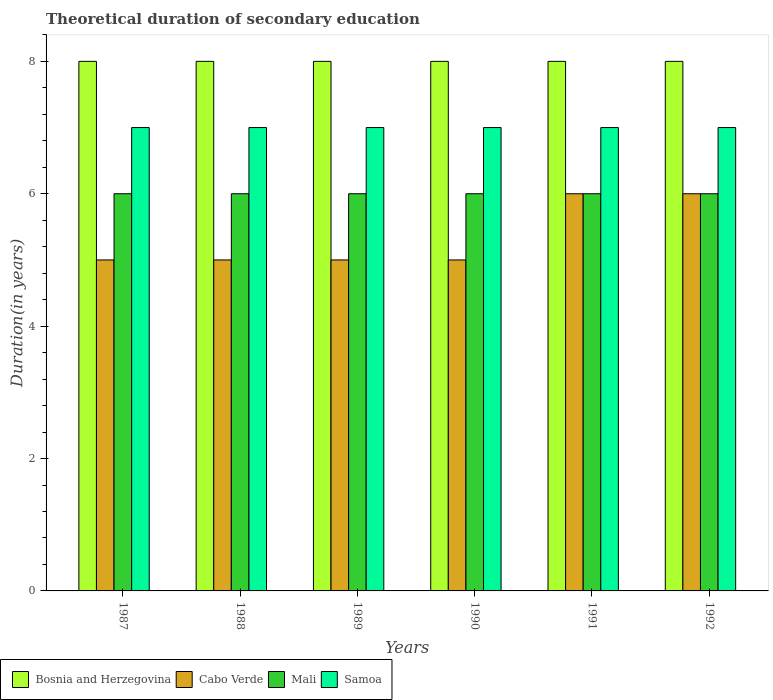How many groups of bars are there?
Your response must be concise. 6. Are the number of bars per tick equal to the number of legend labels?
Your answer should be compact. Yes. Are the number of bars on each tick of the X-axis equal?
Your response must be concise. Yes. How many bars are there on the 4th tick from the left?
Offer a very short reply. 4. How many bars are there on the 3rd tick from the right?
Your answer should be very brief. 4. What is the label of the 2nd group of bars from the left?
Offer a very short reply. 1988. In how many cases, is the number of bars for a given year not equal to the number of legend labels?
Make the answer very short. 0. What is the total theoretical duration of secondary education in Cabo Verde in 1987?
Offer a very short reply. 5. Across all years, what is the maximum total theoretical duration of secondary education in Bosnia and Herzegovina?
Keep it short and to the point. 8. Across all years, what is the minimum total theoretical duration of secondary education in Samoa?
Ensure brevity in your answer.  7. In which year was the total theoretical duration of secondary education in Cabo Verde maximum?
Your response must be concise. 1991. What is the total total theoretical duration of secondary education in Samoa in the graph?
Provide a short and direct response. 42. What is the average total theoretical duration of secondary education in Samoa per year?
Offer a terse response. 7. In the year 1992, what is the difference between the total theoretical duration of secondary education in Samoa and total theoretical duration of secondary education in Bosnia and Herzegovina?
Offer a terse response. -1. Is the difference between the total theoretical duration of secondary education in Samoa in 1987 and 1988 greater than the difference between the total theoretical duration of secondary education in Bosnia and Herzegovina in 1987 and 1988?
Give a very brief answer. No. What is the difference between the highest and the lowest total theoretical duration of secondary education in Samoa?
Give a very brief answer. 0. What does the 2nd bar from the left in 1991 represents?
Your answer should be very brief. Cabo Verde. What does the 1st bar from the right in 1990 represents?
Make the answer very short. Samoa. Is it the case that in every year, the sum of the total theoretical duration of secondary education in Samoa and total theoretical duration of secondary education in Mali is greater than the total theoretical duration of secondary education in Bosnia and Herzegovina?
Your response must be concise. Yes. How many bars are there?
Give a very brief answer. 24. How many years are there in the graph?
Ensure brevity in your answer.  6. What is the difference between two consecutive major ticks on the Y-axis?
Make the answer very short. 2. Does the graph contain any zero values?
Provide a short and direct response. No. How many legend labels are there?
Make the answer very short. 4. How are the legend labels stacked?
Your answer should be very brief. Horizontal. What is the title of the graph?
Your response must be concise. Theoretical duration of secondary education. What is the label or title of the X-axis?
Your answer should be compact. Years. What is the label or title of the Y-axis?
Provide a succinct answer. Duration(in years). What is the Duration(in years) of Mali in 1987?
Ensure brevity in your answer.  6. What is the Duration(in years) of Samoa in 1987?
Provide a succinct answer. 7. What is the Duration(in years) of Samoa in 1988?
Ensure brevity in your answer.  7. What is the Duration(in years) in Bosnia and Herzegovina in 1989?
Make the answer very short. 8. What is the Duration(in years) of Cabo Verde in 1990?
Provide a succinct answer. 5. What is the Duration(in years) of Bosnia and Herzegovina in 1991?
Keep it short and to the point. 8. What is the Duration(in years) of Mali in 1991?
Give a very brief answer. 6. What is the Duration(in years) of Bosnia and Herzegovina in 1992?
Provide a short and direct response. 8. What is the Duration(in years) in Cabo Verde in 1992?
Your answer should be compact. 6. Across all years, what is the maximum Duration(in years) of Bosnia and Herzegovina?
Your response must be concise. 8. Across all years, what is the maximum Duration(in years) in Cabo Verde?
Offer a very short reply. 6. Across all years, what is the maximum Duration(in years) in Mali?
Your answer should be very brief. 6. Across all years, what is the maximum Duration(in years) in Samoa?
Make the answer very short. 7. Across all years, what is the minimum Duration(in years) of Bosnia and Herzegovina?
Give a very brief answer. 8. Across all years, what is the minimum Duration(in years) of Samoa?
Offer a very short reply. 7. What is the total Duration(in years) of Mali in the graph?
Your answer should be very brief. 36. What is the total Duration(in years) in Samoa in the graph?
Your answer should be compact. 42. What is the difference between the Duration(in years) of Bosnia and Herzegovina in 1987 and that in 1988?
Offer a very short reply. 0. What is the difference between the Duration(in years) of Cabo Verde in 1987 and that in 1988?
Ensure brevity in your answer.  0. What is the difference between the Duration(in years) of Samoa in 1987 and that in 1988?
Your answer should be compact. 0. What is the difference between the Duration(in years) of Bosnia and Herzegovina in 1987 and that in 1989?
Provide a succinct answer. 0. What is the difference between the Duration(in years) of Cabo Verde in 1987 and that in 1989?
Make the answer very short. 0. What is the difference between the Duration(in years) of Mali in 1987 and that in 1989?
Provide a short and direct response. 0. What is the difference between the Duration(in years) in Samoa in 1987 and that in 1989?
Your response must be concise. 0. What is the difference between the Duration(in years) of Bosnia and Herzegovina in 1987 and that in 1990?
Offer a terse response. 0. What is the difference between the Duration(in years) in Mali in 1987 and that in 1990?
Your answer should be compact. 0. What is the difference between the Duration(in years) in Samoa in 1987 and that in 1990?
Keep it short and to the point. 0. What is the difference between the Duration(in years) of Cabo Verde in 1987 and that in 1991?
Offer a very short reply. -1. What is the difference between the Duration(in years) in Mali in 1987 and that in 1991?
Offer a terse response. 0. What is the difference between the Duration(in years) in Bosnia and Herzegovina in 1987 and that in 1992?
Offer a very short reply. 0. What is the difference between the Duration(in years) of Mali in 1987 and that in 1992?
Offer a terse response. 0. What is the difference between the Duration(in years) in Cabo Verde in 1988 and that in 1989?
Offer a very short reply. 0. What is the difference between the Duration(in years) of Cabo Verde in 1988 and that in 1990?
Offer a very short reply. 0. What is the difference between the Duration(in years) of Samoa in 1988 and that in 1990?
Offer a terse response. 0. What is the difference between the Duration(in years) of Mali in 1988 and that in 1991?
Give a very brief answer. 0. What is the difference between the Duration(in years) in Bosnia and Herzegovina in 1988 and that in 1992?
Make the answer very short. 0. What is the difference between the Duration(in years) of Cabo Verde in 1988 and that in 1992?
Make the answer very short. -1. What is the difference between the Duration(in years) in Samoa in 1988 and that in 1992?
Offer a very short reply. 0. What is the difference between the Duration(in years) in Bosnia and Herzegovina in 1989 and that in 1990?
Make the answer very short. 0. What is the difference between the Duration(in years) in Cabo Verde in 1989 and that in 1990?
Offer a very short reply. 0. What is the difference between the Duration(in years) in Bosnia and Herzegovina in 1989 and that in 1991?
Your answer should be very brief. 0. What is the difference between the Duration(in years) of Cabo Verde in 1989 and that in 1991?
Ensure brevity in your answer.  -1. What is the difference between the Duration(in years) of Mali in 1989 and that in 1991?
Keep it short and to the point. 0. What is the difference between the Duration(in years) in Mali in 1989 and that in 1992?
Ensure brevity in your answer.  0. What is the difference between the Duration(in years) in Mali in 1990 and that in 1991?
Make the answer very short. 0. What is the difference between the Duration(in years) of Samoa in 1990 and that in 1992?
Offer a terse response. 0. What is the difference between the Duration(in years) of Cabo Verde in 1991 and that in 1992?
Give a very brief answer. 0. What is the difference between the Duration(in years) of Mali in 1991 and that in 1992?
Offer a very short reply. 0. What is the difference between the Duration(in years) in Bosnia and Herzegovina in 1987 and the Duration(in years) in Mali in 1988?
Keep it short and to the point. 2. What is the difference between the Duration(in years) in Bosnia and Herzegovina in 1987 and the Duration(in years) in Samoa in 1989?
Offer a very short reply. 1. What is the difference between the Duration(in years) in Cabo Verde in 1987 and the Duration(in years) in Mali in 1989?
Give a very brief answer. -1. What is the difference between the Duration(in years) in Mali in 1987 and the Duration(in years) in Samoa in 1989?
Keep it short and to the point. -1. What is the difference between the Duration(in years) of Bosnia and Herzegovina in 1987 and the Duration(in years) of Cabo Verde in 1990?
Your answer should be very brief. 3. What is the difference between the Duration(in years) of Bosnia and Herzegovina in 1987 and the Duration(in years) of Mali in 1990?
Provide a succinct answer. 2. What is the difference between the Duration(in years) of Cabo Verde in 1987 and the Duration(in years) of Mali in 1990?
Offer a very short reply. -1. What is the difference between the Duration(in years) of Cabo Verde in 1987 and the Duration(in years) of Samoa in 1990?
Offer a very short reply. -2. What is the difference between the Duration(in years) in Mali in 1987 and the Duration(in years) in Samoa in 1990?
Your response must be concise. -1. What is the difference between the Duration(in years) of Bosnia and Herzegovina in 1987 and the Duration(in years) of Cabo Verde in 1991?
Offer a very short reply. 2. What is the difference between the Duration(in years) of Bosnia and Herzegovina in 1987 and the Duration(in years) of Samoa in 1991?
Keep it short and to the point. 1. What is the difference between the Duration(in years) of Cabo Verde in 1987 and the Duration(in years) of Mali in 1991?
Offer a very short reply. -1. What is the difference between the Duration(in years) in Bosnia and Herzegovina in 1987 and the Duration(in years) in Mali in 1992?
Provide a succinct answer. 2. What is the difference between the Duration(in years) in Bosnia and Herzegovina in 1987 and the Duration(in years) in Samoa in 1992?
Provide a succinct answer. 1. What is the difference between the Duration(in years) in Cabo Verde in 1987 and the Duration(in years) in Samoa in 1992?
Your response must be concise. -2. What is the difference between the Duration(in years) in Mali in 1987 and the Duration(in years) in Samoa in 1992?
Give a very brief answer. -1. What is the difference between the Duration(in years) in Bosnia and Herzegovina in 1988 and the Duration(in years) in Cabo Verde in 1989?
Keep it short and to the point. 3. What is the difference between the Duration(in years) of Bosnia and Herzegovina in 1988 and the Duration(in years) of Samoa in 1989?
Your answer should be compact. 1. What is the difference between the Duration(in years) of Mali in 1988 and the Duration(in years) of Samoa in 1989?
Your answer should be very brief. -1. What is the difference between the Duration(in years) of Bosnia and Herzegovina in 1988 and the Duration(in years) of Mali in 1990?
Your answer should be compact. 2. What is the difference between the Duration(in years) in Cabo Verde in 1988 and the Duration(in years) in Mali in 1990?
Make the answer very short. -1. What is the difference between the Duration(in years) in Mali in 1988 and the Duration(in years) in Samoa in 1990?
Make the answer very short. -1. What is the difference between the Duration(in years) in Bosnia and Herzegovina in 1988 and the Duration(in years) in Cabo Verde in 1991?
Your answer should be compact. 2. What is the difference between the Duration(in years) in Mali in 1988 and the Duration(in years) in Samoa in 1991?
Keep it short and to the point. -1. What is the difference between the Duration(in years) in Bosnia and Herzegovina in 1988 and the Duration(in years) in Cabo Verde in 1992?
Your response must be concise. 2. What is the difference between the Duration(in years) in Bosnia and Herzegovina in 1988 and the Duration(in years) in Mali in 1992?
Offer a terse response. 2. What is the difference between the Duration(in years) of Bosnia and Herzegovina in 1988 and the Duration(in years) of Samoa in 1992?
Keep it short and to the point. 1. What is the difference between the Duration(in years) in Cabo Verde in 1988 and the Duration(in years) in Mali in 1992?
Your answer should be compact. -1. What is the difference between the Duration(in years) in Cabo Verde in 1988 and the Duration(in years) in Samoa in 1992?
Your response must be concise. -2. What is the difference between the Duration(in years) of Mali in 1988 and the Duration(in years) of Samoa in 1992?
Make the answer very short. -1. What is the difference between the Duration(in years) of Bosnia and Herzegovina in 1989 and the Duration(in years) of Cabo Verde in 1990?
Ensure brevity in your answer.  3. What is the difference between the Duration(in years) of Bosnia and Herzegovina in 1989 and the Duration(in years) of Samoa in 1990?
Keep it short and to the point. 1. What is the difference between the Duration(in years) in Cabo Verde in 1989 and the Duration(in years) in Mali in 1990?
Offer a very short reply. -1. What is the difference between the Duration(in years) in Mali in 1989 and the Duration(in years) in Samoa in 1990?
Your answer should be very brief. -1. What is the difference between the Duration(in years) of Bosnia and Herzegovina in 1989 and the Duration(in years) of Cabo Verde in 1991?
Keep it short and to the point. 2. What is the difference between the Duration(in years) of Bosnia and Herzegovina in 1989 and the Duration(in years) of Mali in 1991?
Make the answer very short. 2. What is the difference between the Duration(in years) of Cabo Verde in 1989 and the Duration(in years) of Samoa in 1991?
Keep it short and to the point. -2. What is the difference between the Duration(in years) of Mali in 1989 and the Duration(in years) of Samoa in 1991?
Ensure brevity in your answer.  -1. What is the difference between the Duration(in years) of Cabo Verde in 1989 and the Duration(in years) of Samoa in 1992?
Make the answer very short. -2. What is the difference between the Duration(in years) of Cabo Verde in 1990 and the Duration(in years) of Mali in 1991?
Your answer should be very brief. -1. What is the difference between the Duration(in years) of Cabo Verde in 1990 and the Duration(in years) of Samoa in 1991?
Make the answer very short. -2. What is the difference between the Duration(in years) of Bosnia and Herzegovina in 1990 and the Duration(in years) of Cabo Verde in 1992?
Provide a short and direct response. 2. What is the difference between the Duration(in years) in Bosnia and Herzegovina in 1990 and the Duration(in years) in Mali in 1992?
Provide a short and direct response. 2. What is the difference between the Duration(in years) of Cabo Verde in 1990 and the Duration(in years) of Mali in 1992?
Your answer should be very brief. -1. What is the difference between the Duration(in years) of Cabo Verde in 1990 and the Duration(in years) of Samoa in 1992?
Your answer should be compact. -2. What is the difference between the Duration(in years) in Mali in 1990 and the Duration(in years) in Samoa in 1992?
Ensure brevity in your answer.  -1. What is the difference between the Duration(in years) in Bosnia and Herzegovina in 1991 and the Duration(in years) in Mali in 1992?
Your answer should be very brief. 2. What is the difference between the Duration(in years) of Bosnia and Herzegovina in 1991 and the Duration(in years) of Samoa in 1992?
Give a very brief answer. 1. What is the difference between the Duration(in years) of Cabo Verde in 1991 and the Duration(in years) of Mali in 1992?
Your response must be concise. 0. What is the difference between the Duration(in years) in Cabo Verde in 1991 and the Duration(in years) in Samoa in 1992?
Offer a terse response. -1. What is the average Duration(in years) of Bosnia and Herzegovina per year?
Ensure brevity in your answer.  8. What is the average Duration(in years) in Cabo Verde per year?
Provide a succinct answer. 5.33. What is the average Duration(in years) in Mali per year?
Ensure brevity in your answer.  6. What is the average Duration(in years) of Samoa per year?
Your response must be concise. 7. In the year 1987, what is the difference between the Duration(in years) in Bosnia and Herzegovina and Duration(in years) in Cabo Verde?
Ensure brevity in your answer.  3. In the year 1987, what is the difference between the Duration(in years) in Bosnia and Herzegovina and Duration(in years) in Mali?
Your answer should be very brief. 2. In the year 1987, what is the difference between the Duration(in years) of Bosnia and Herzegovina and Duration(in years) of Samoa?
Ensure brevity in your answer.  1. In the year 1987, what is the difference between the Duration(in years) of Cabo Verde and Duration(in years) of Mali?
Offer a terse response. -1. In the year 1987, what is the difference between the Duration(in years) in Cabo Verde and Duration(in years) in Samoa?
Offer a terse response. -2. In the year 1988, what is the difference between the Duration(in years) of Bosnia and Herzegovina and Duration(in years) of Mali?
Ensure brevity in your answer.  2. In the year 1988, what is the difference between the Duration(in years) in Mali and Duration(in years) in Samoa?
Make the answer very short. -1. In the year 1989, what is the difference between the Duration(in years) in Cabo Verde and Duration(in years) in Mali?
Your response must be concise. -1. In the year 1989, what is the difference between the Duration(in years) of Cabo Verde and Duration(in years) of Samoa?
Make the answer very short. -2. In the year 1989, what is the difference between the Duration(in years) of Mali and Duration(in years) of Samoa?
Keep it short and to the point. -1. In the year 1990, what is the difference between the Duration(in years) of Bosnia and Herzegovina and Duration(in years) of Cabo Verde?
Ensure brevity in your answer.  3. In the year 1990, what is the difference between the Duration(in years) in Bosnia and Herzegovina and Duration(in years) in Samoa?
Keep it short and to the point. 1. In the year 1990, what is the difference between the Duration(in years) in Cabo Verde and Duration(in years) in Samoa?
Ensure brevity in your answer.  -2. In the year 1991, what is the difference between the Duration(in years) in Bosnia and Herzegovina and Duration(in years) in Mali?
Your response must be concise. 2. In the year 1991, what is the difference between the Duration(in years) in Cabo Verde and Duration(in years) in Samoa?
Offer a very short reply. -1. In the year 1992, what is the difference between the Duration(in years) of Bosnia and Herzegovina and Duration(in years) of Samoa?
Offer a terse response. 1. In the year 1992, what is the difference between the Duration(in years) in Mali and Duration(in years) in Samoa?
Offer a very short reply. -1. What is the ratio of the Duration(in years) in Bosnia and Herzegovina in 1987 to that in 1988?
Offer a terse response. 1. What is the ratio of the Duration(in years) of Cabo Verde in 1987 to that in 1988?
Your answer should be very brief. 1. What is the ratio of the Duration(in years) in Samoa in 1987 to that in 1988?
Offer a very short reply. 1. What is the ratio of the Duration(in years) in Samoa in 1987 to that in 1990?
Make the answer very short. 1. What is the ratio of the Duration(in years) of Bosnia and Herzegovina in 1987 to that in 1991?
Your answer should be very brief. 1. What is the ratio of the Duration(in years) of Cabo Verde in 1987 to that in 1991?
Your answer should be very brief. 0.83. What is the ratio of the Duration(in years) of Samoa in 1987 to that in 1991?
Make the answer very short. 1. What is the ratio of the Duration(in years) in Mali in 1987 to that in 1992?
Offer a very short reply. 1. What is the ratio of the Duration(in years) of Samoa in 1987 to that in 1992?
Your answer should be compact. 1. What is the ratio of the Duration(in years) in Mali in 1988 to that in 1989?
Your answer should be very brief. 1. What is the ratio of the Duration(in years) of Samoa in 1988 to that in 1989?
Provide a succinct answer. 1. What is the ratio of the Duration(in years) of Bosnia and Herzegovina in 1988 to that in 1990?
Offer a terse response. 1. What is the ratio of the Duration(in years) in Samoa in 1988 to that in 1990?
Keep it short and to the point. 1. What is the ratio of the Duration(in years) of Bosnia and Herzegovina in 1988 to that in 1991?
Provide a short and direct response. 1. What is the ratio of the Duration(in years) in Cabo Verde in 1988 to that in 1991?
Offer a very short reply. 0.83. What is the ratio of the Duration(in years) of Mali in 1988 to that in 1991?
Offer a terse response. 1. What is the ratio of the Duration(in years) in Bosnia and Herzegovina in 1988 to that in 1992?
Make the answer very short. 1. What is the ratio of the Duration(in years) of Mali in 1988 to that in 1992?
Your answer should be very brief. 1. What is the ratio of the Duration(in years) in Bosnia and Herzegovina in 1989 to that in 1990?
Your response must be concise. 1. What is the ratio of the Duration(in years) in Cabo Verde in 1989 to that in 1990?
Keep it short and to the point. 1. What is the ratio of the Duration(in years) in Samoa in 1989 to that in 1990?
Offer a very short reply. 1. What is the ratio of the Duration(in years) of Cabo Verde in 1989 to that in 1991?
Offer a very short reply. 0.83. What is the ratio of the Duration(in years) of Bosnia and Herzegovina in 1989 to that in 1992?
Make the answer very short. 1. What is the ratio of the Duration(in years) of Cabo Verde in 1990 to that in 1991?
Offer a terse response. 0.83. What is the ratio of the Duration(in years) in Samoa in 1990 to that in 1991?
Ensure brevity in your answer.  1. What is the ratio of the Duration(in years) of Cabo Verde in 1991 to that in 1992?
Your answer should be compact. 1. What is the ratio of the Duration(in years) of Mali in 1991 to that in 1992?
Make the answer very short. 1. What is the ratio of the Duration(in years) in Samoa in 1991 to that in 1992?
Offer a very short reply. 1. What is the difference between the highest and the second highest Duration(in years) of Bosnia and Herzegovina?
Offer a very short reply. 0. What is the difference between the highest and the second highest Duration(in years) of Samoa?
Offer a very short reply. 0. What is the difference between the highest and the lowest Duration(in years) in Bosnia and Herzegovina?
Make the answer very short. 0. What is the difference between the highest and the lowest Duration(in years) of Cabo Verde?
Your response must be concise. 1. 